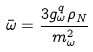Convert formula to latex. <formula><loc_0><loc_0><loc_500><loc_500>\bar { \omega } = \frac { 3 g _ { \omega } ^ { q } \rho _ { N } } { m _ { \omega } ^ { 2 } }</formula> 